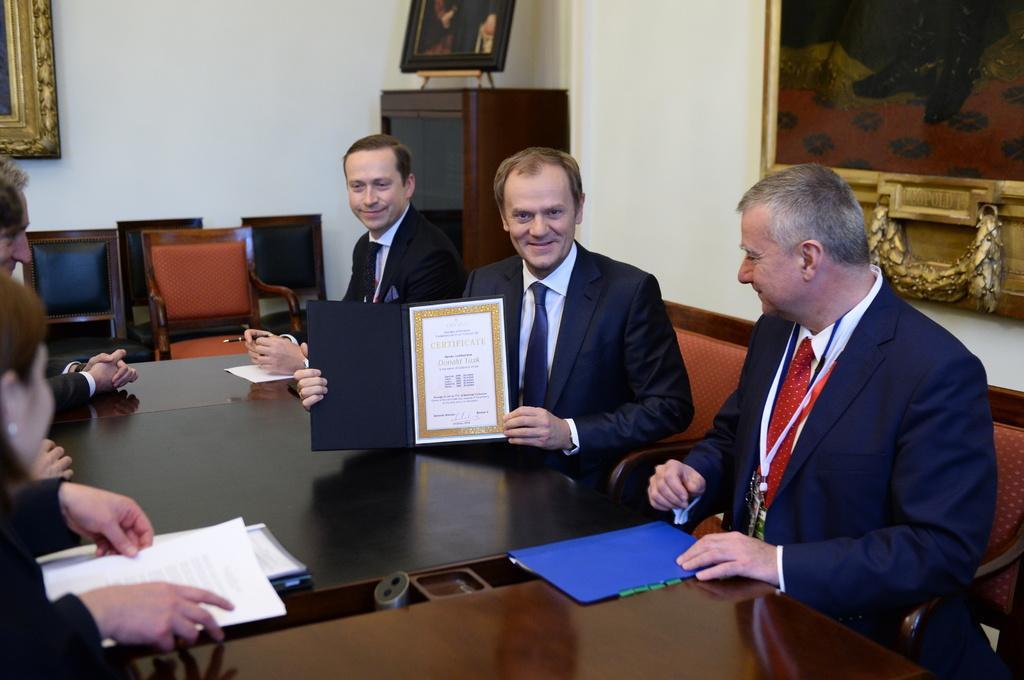In one or two sentences, can you explain what this image depicts? There are five persons sitting on the chairs among them one man is holding and showing certificate. This is a table with file,papers on it. These are the empty chairs. At background I can see some wooden object with some photo frame placed on it. At the top left corner I can see a frame which is attached to the wall and I can see another frame attached to the wall. 